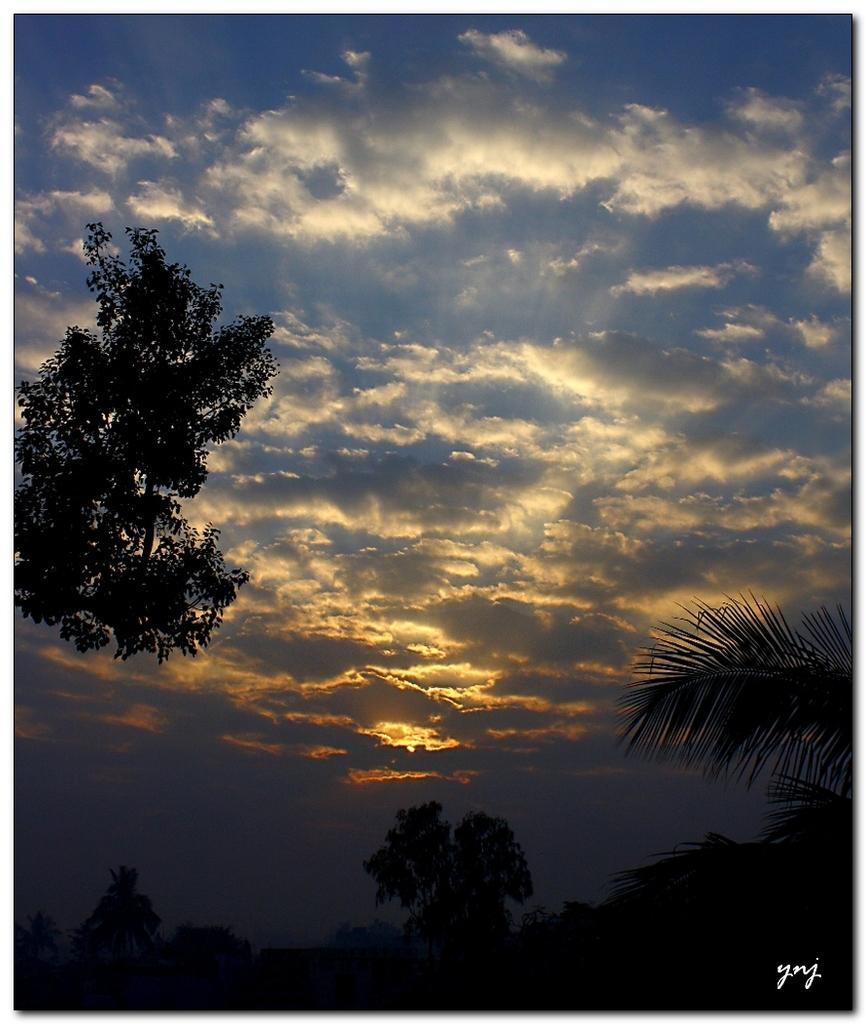In one or two sentences, can you explain what this image depicts? In this picture we can see some trees, there is a cloudy sky at the top of the picture, at the right bottom we can see some text. 